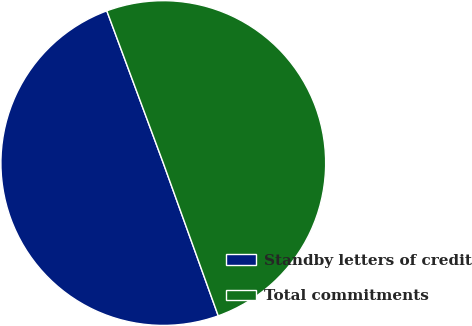<chart> <loc_0><loc_0><loc_500><loc_500><pie_chart><fcel>Standby letters of credit<fcel>Total commitments<nl><fcel>49.84%<fcel>50.16%<nl></chart> 